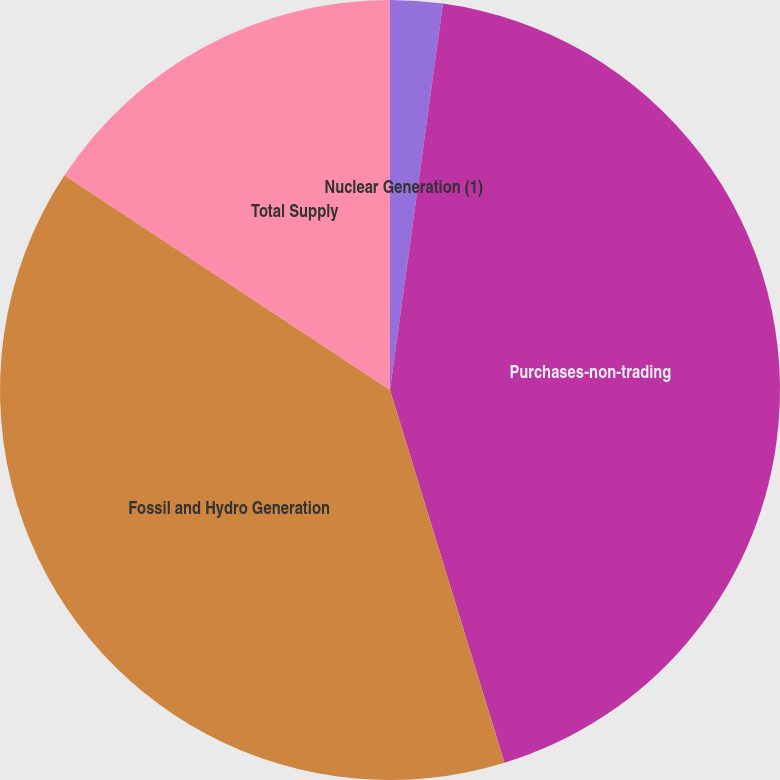<chart> <loc_0><loc_0><loc_500><loc_500><pie_chart><fcel>Nuclear Generation (1)<fcel>Purchases-non-trading<fcel>Fossil and Hydro Generation<fcel>Total Supply<nl><fcel>2.17%<fcel>43.09%<fcel>39.02%<fcel>15.72%<nl></chart> 